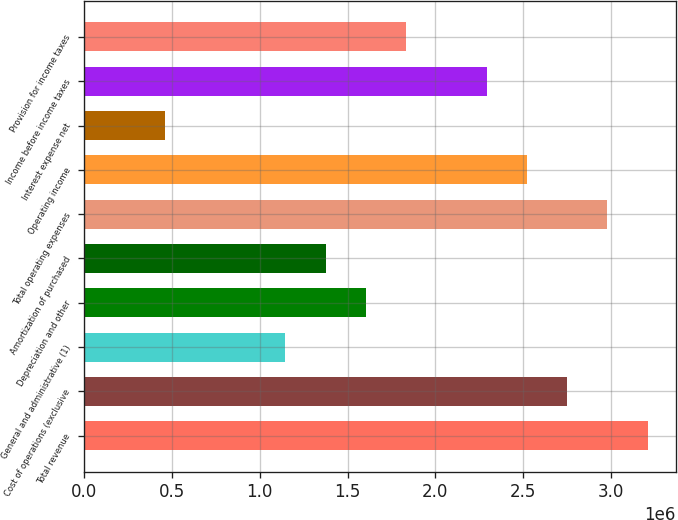Convert chart. <chart><loc_0><loc_0><loc_500><loc_500><bar_chart><fcel>Total revenue<fcel>Cost of operations (exclusive<fcel>General and administrative (1)<fcel>Depreciation and other<fcel>Amortization of purchased<fcel>Total operating expenses<fcel>Operating income<fcel>Interest expense net<fcel>Income before income taxes<fcel>Provision for income taxes<nl><fcel>3.20766e+06<fcel>2.74943e+06<fcel>1.1456e+06<fcel>1.60383e+06<fcel>1.37471e+06<fcel>2.97855e+06<fcel>2.52031e+06<fcel>458239<fcel>2.29119e+06<fcel>1.83295e+06<nl></chart> 